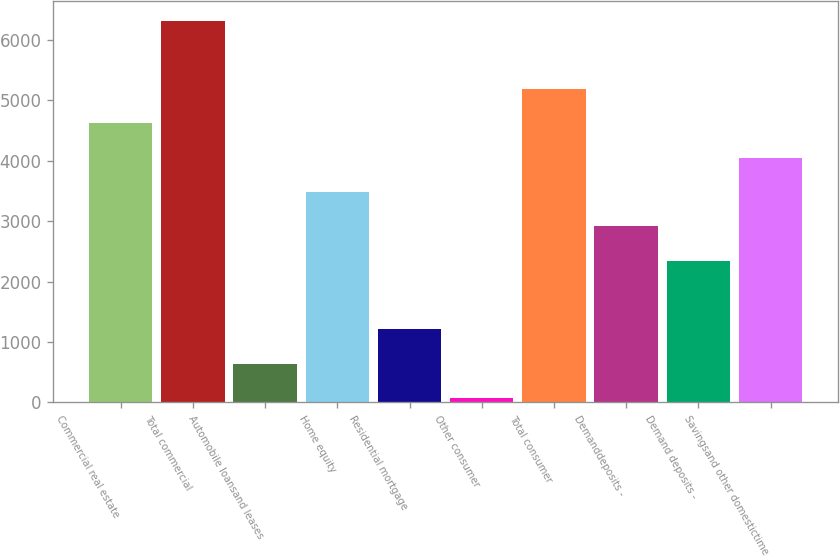Convert chart. <chart><loc_0><loc_0><loc_500><loc_500><bar_chart><fcel>Commercial real estate<fcel>Total commercial<fcel>Automobile loansand leases<fcel>Home equity<fcel>Residential mortgage<fcel>Other consumer<fcel>Total consumer<fcel>Demanddeposits -<fcel>Demand deposits -<fcel>Savingsand other domestictime<nl><fcel>4618.4<fcel>6323.3<fcel>640.3<fcel>3481.8<fcel>1208.6<fcel>72<fcel>5186.7<fcel>2913.5<fcel>2345.2<fcel>4050.1<nl></chart> 